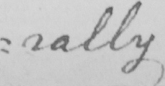What is written in this line of handwriting? : rally 